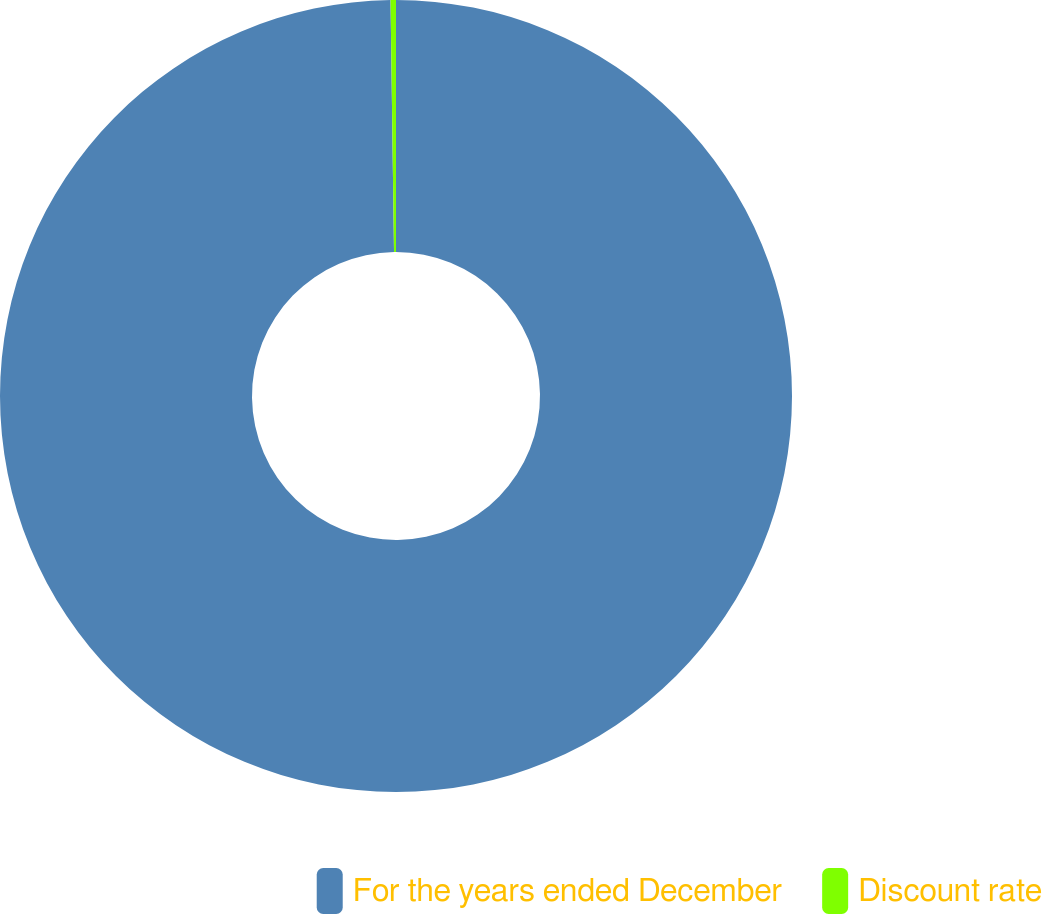<chart> <loc_0><loc_0><loc_500><loc_500><pie_chart><fcel>For the years ended December<fcel>Discount rate<nl><fcel>99.78%<fcel>0.22%<nl></chart> 